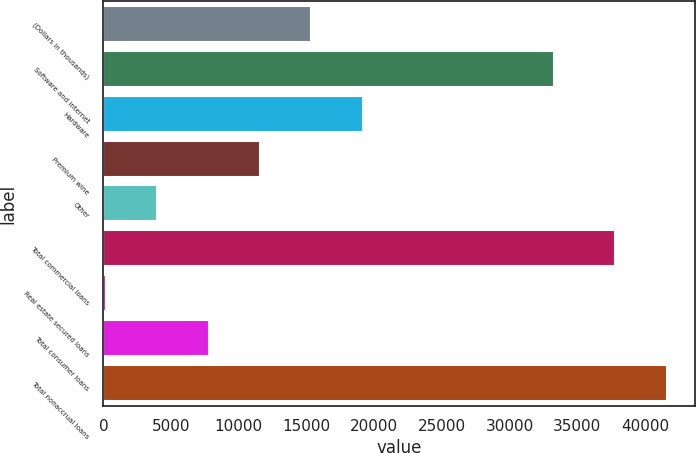Convert chart. <chart><loc_0><loc_0><loc_500><loc_500><bar_chart><fcel>(Dollars in thousands)<fcel>Software and internet<fcel>Hardware<fcel>Premium wine<fcel>Other<fcel>Total commercial loans<fcel>Real estate secured loans<fcel>Total consumer loans<fcel>Total nonaccrual loans<nl><fcel>15370<fcel>33287<fcel>19164.5<fcel>11575.5<fcel>3986.5<fcel>37820<fcel>192<fcel>7781<fcel>41614.5<nl></chart> 